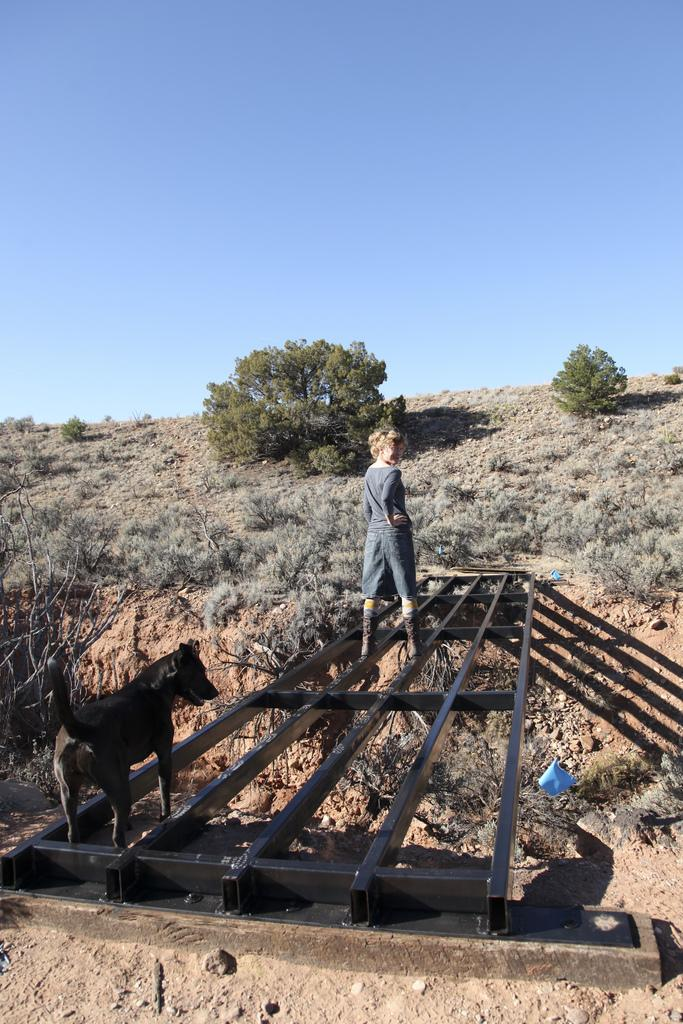What is the person doing in the image? The person is standing on a bridge in the image. Is there any other living creature present on the bridge? Yes, there is a dog on the bridge. What can be seen in the background of the image? There are trees, plants, grass on a hill, and a blue sky in the background of the image. What type of cherry is the person holding in the image? There is no cherry present in the image; the person is standing on a bridge with a dog. How many cushions are visible in the image? There are no cushions present in the image. 